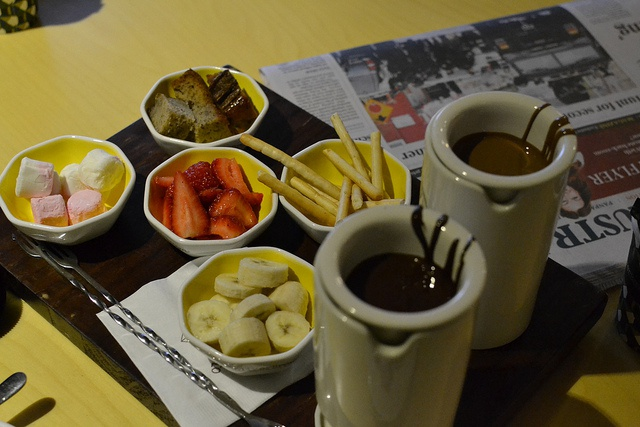Describe the objects in this image and their specific colors. I can see cup in black, darkgreen, and gray tones, cup in black, gray, and darkgreen tones, bowl in black, olive, and darkgray tones, bowl in black, olive, darkgray, and tan tones, and bowl in black, maroon, and brown tones in this image. 